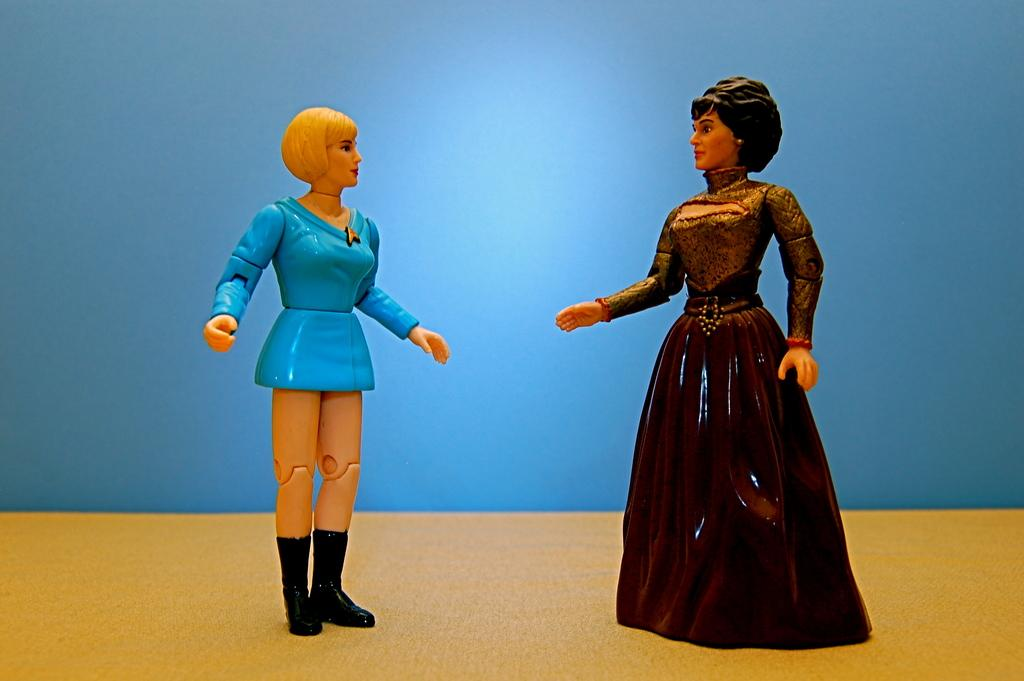What objects are present in the image? There are two toys in the image. Where are the toys located? The toys are on a platform. What color is the background of the image? The background of the image is blue. How many oranges are on the cushion in the image? There are no oranges or cushions present in the image. What type of behavior can be observed in the toys in the image? The toys are inanimate objects and do not exhibit behavior. 